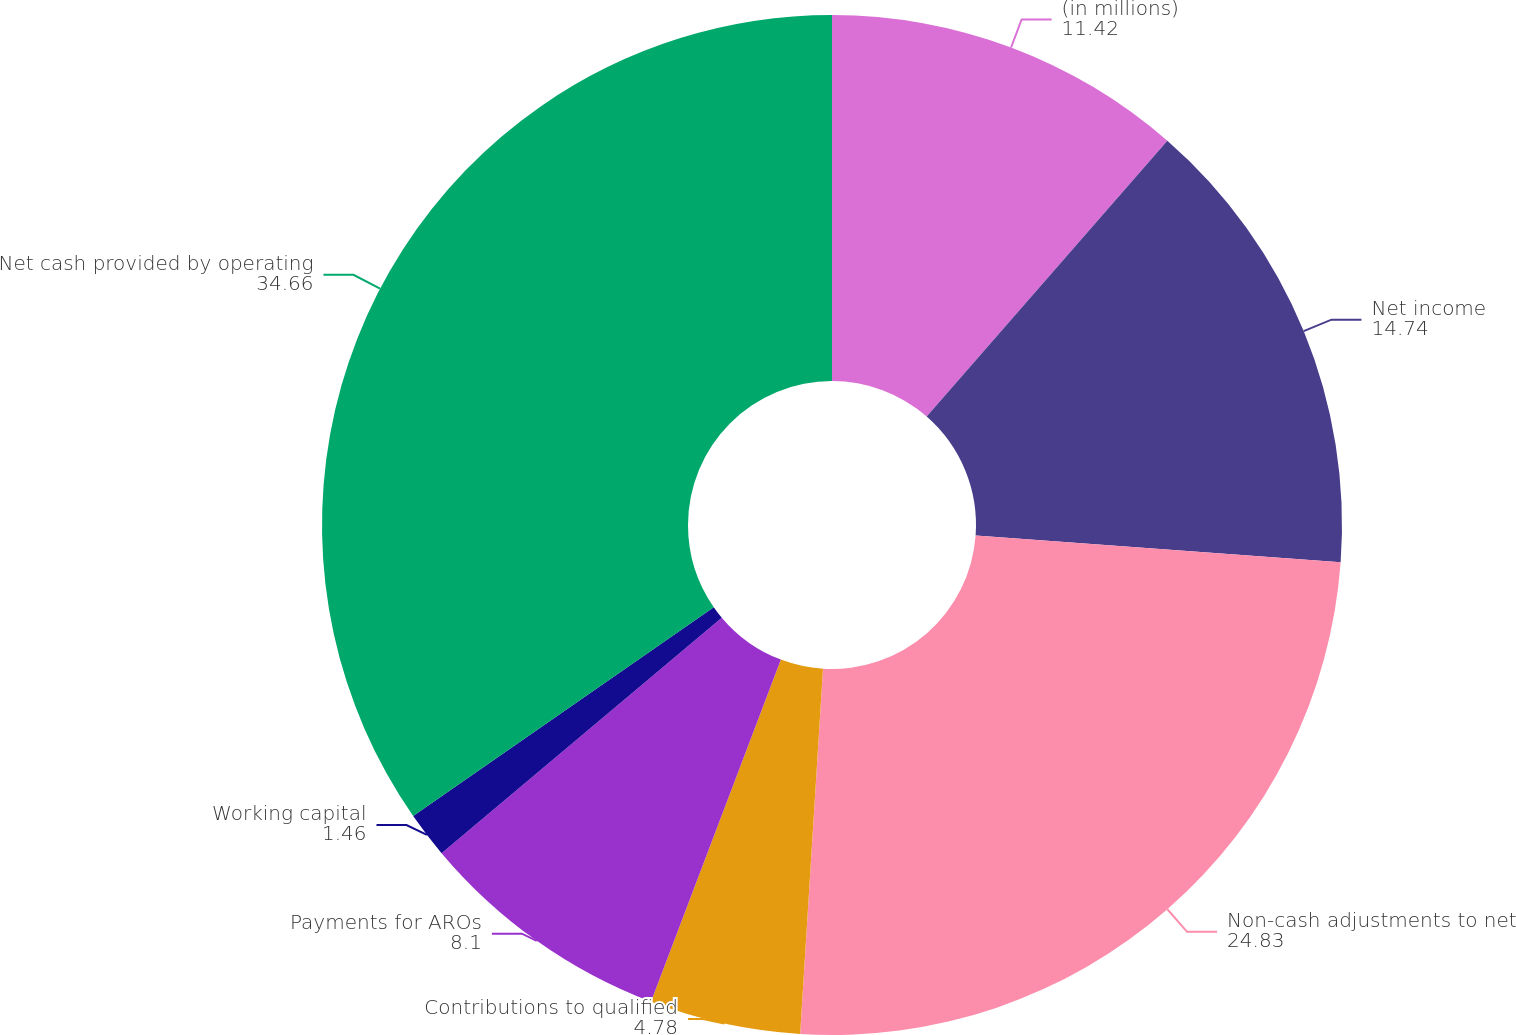Convert chart to OTSL. <chart><loc_0><loc_0><loc_500><loc_500><pie_chart><fcel>(in millions)<fcel>Net income<fcel>Non-cash adjustments to net<fcel>Contributions to qualified<fcel>Payments for AROs<fcel>Working capital<fcel>Net cash provided by operating<nl><fcel>11.42%<fcel>14.74%<fcel>24.83%<fcel>4.78%<fcel>8.1%<fcel>1.46%<fcel>34.66%<nl></chart> 